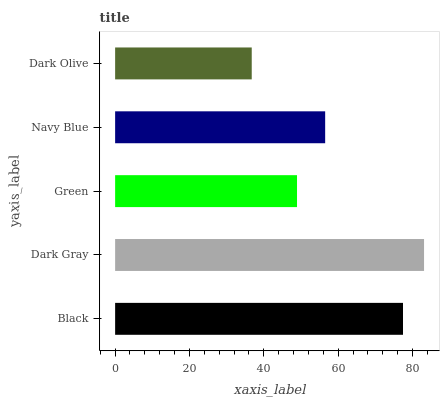Is Dark Olive the minimum?
Answer yes or no. Yes. Is Dark Gray the maximum?
Answer yes or no. Yes. Is Green the minimum?
Answer yes or no. No. Is Green the maximum?
Answer yes or no. No. Is Dark Gray greater than Green?
Answer yes or no. Yes. Is Green less than Dark Gray?
Answer yes or no. Yes. Is Green greater than Dark Gray?
Answer yes or no. No. Is Dark Gray less than Green?
Answer yes or no. No. Is Navy Blue the high median?
Answer yes or no. Yes. Is Navy Blue the low median?
Answer yes or no. Yes. Is Black the high median?
Answer yes or no. No. Is Dark Olive the low median?
Answer yes or no. No. 